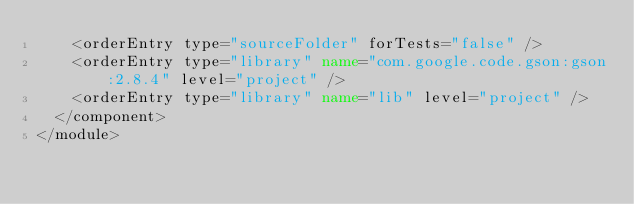<code> <loc_0><loc_0><loc_500><loc_500><_XML_>    <orderEntry type="sourceFolder" forTests="false" />
    <orderEntry type="library" name="com.google.code.gson:gson:2.8.4" level="project" />
    <orderEntry type="library" name="lib" level="project" />
  </component>
</module></code> 